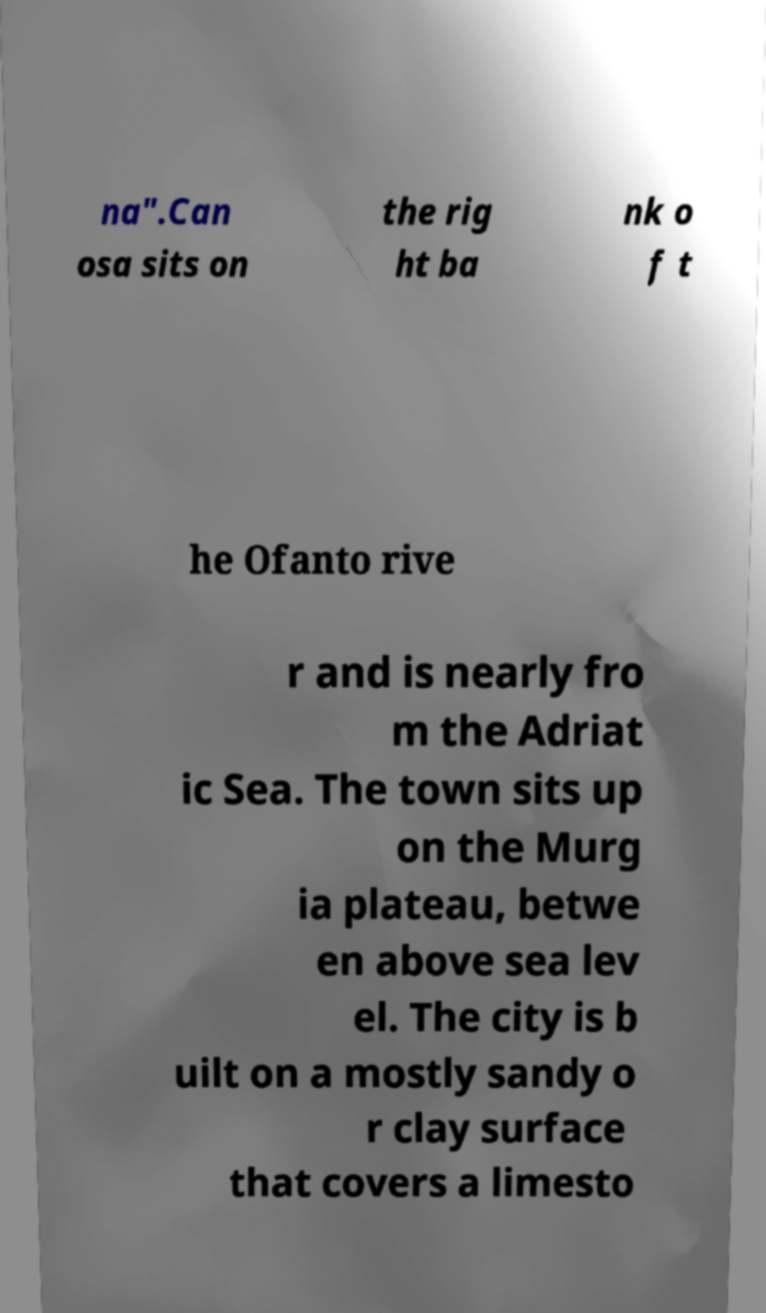I need the written content from this picture converted into text. Can you do that? na".Can osa sits on the rig ht ba nk o f t he Ofanto rive r and is nearly fro m the Adriat ic Sea. The town sits up on the Murg ia plateau, betwe en above sea lev el. The city is b uilt on a mostly sandy o r clay surface that covers a limesto 